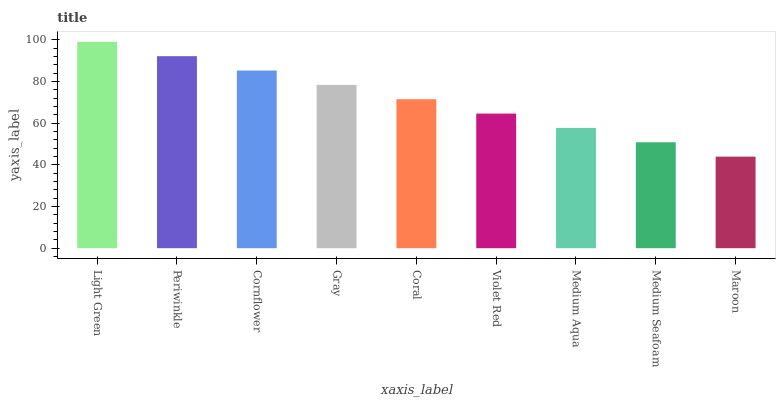Is Maroon the minimum?
Answer yes or no. Yes. Is Light Green the maximum?
Answer yes or no. Yes. Is Periwinkle the minimum?
Answer yes or no. No. Is Periwinkle the maximum?
Answer yes or no. No. Is Light Green greater than Periwinkle?
Answer yes or no. Yes. Is Periwinkle less than Light Green?
Answer yes or no. Yes. Is Periwinkle greater than Light Green?
Answer yes or no. No. Is Light Green less than Periwinkle?
Answer yes or no. No. Is Coral the high median?
Answer yes or no. Yes. Is Coral the low median?
Answer yes or no. Yes. Is Medium Seafoam the high median?
Answer yes or no. No. Is Periwinkle the low median?
Answer yes or no. No. 